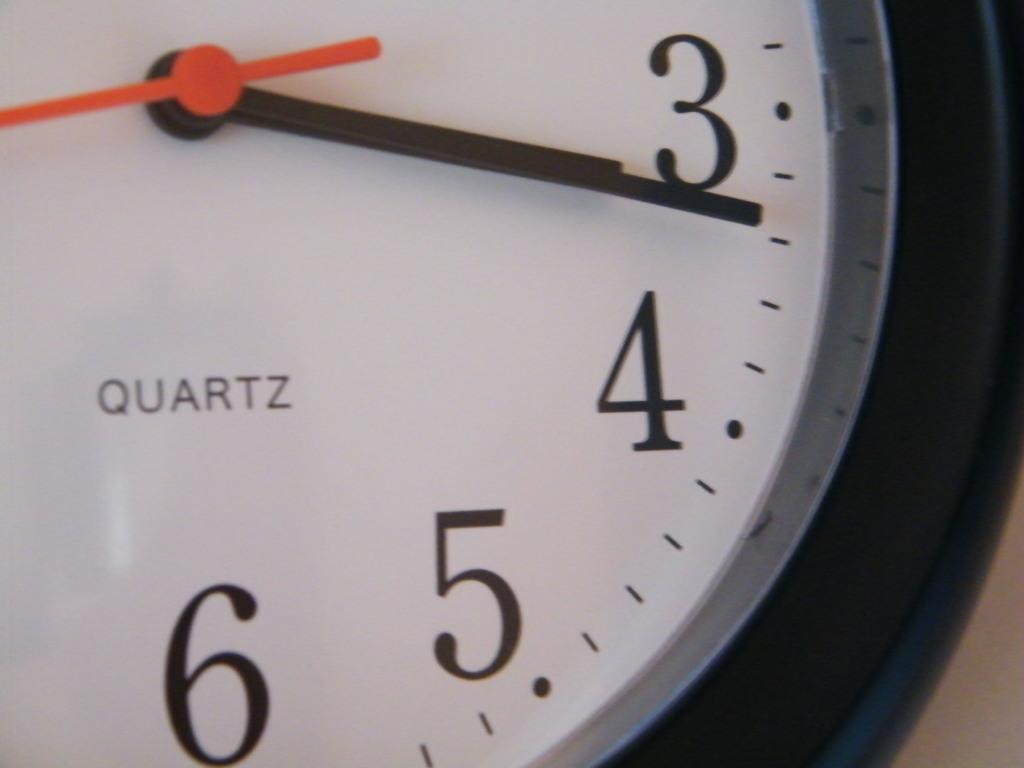Is this a clock?
Your response must be concise. Yes. 